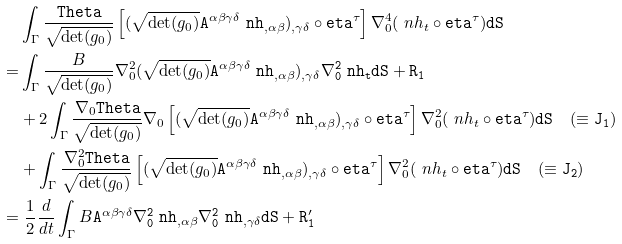Convert formula to latex. <formula><loc_0><loc_0><loc_500><loc_500>& \int _ { \Gamma } \frac { \tt T h e t a } { \sqrt { \det ( g _ { 0 } ) } } \left [ ( \sqrt { \det ( g _ { 0 } ) } \tt A ^ { \alpha \beta \gamma \delta } \ n h _ { , \alpha \beta } ) _ { , \gamma \delta } \circ \tt e t a ^ { \tau } \right ] \nabla _ { 0 } ^ { 4 } ( \ n h _ { t } \circ \tt e t a ^ { \tau } ) d S \\ = & \int _ { \Gamma } \frac { B } { \sqrt { \det ( g _ { 0 } ) } } \nabla _ { 0 } ^ { 2 } ( \sqrt { \det ( g _ { 0 } ) } \tt A ^ { \alpha \beta \gamma \delta } \ n h _ { , \alpha \beta } ) _ { , \gamma \delta } \nabla _ { 0 } ^ { 2 } \ n h _ { t } d S + R _ { 1 } \\ & + 2 \int _ { \Gamma } \frac { \nabla _ { 0 } \tt T h e t a } { \sqrt { \det ( g _ { 0 } ) } } \nabla _ { 0 } \left [ ( \sqrt { \det ( g _ { 0 } ) } \tt A ^ { \alpha \beta \gamma \delta } \ n h _ { , \alpha \beta } ) _ { , \gamma \delta } \circ \tt e t a ^ { \tau } \right ] \nabla _ { 0 } ^ { 2 } ( \ n h _ { t } \circ \tt e t a ^ { \tau } ) d S \quad ( \equiv J _ { 1 } ) \\ & + \int _ { \Gamma } \frac { \nabla _ { 0 } ^ { 2 } \tt T h e t a } { \sqrt { \det ( g _ { 0 } ) } } \left [ ( \sqrt { \det ( g _ { 0 } ) } \tt A ^ { \alpha \beta \gamma \delta } \ n h _ { , \alpha \beta } ) _ { , \gamma \delta } \circ \tt e t a ^ { \tau } \right ] \nabla _ { 0 } ^ { 2 } ( \ n h _ { t } \circ \tt e t a ^ { \tau } ) d S \quad ( \equiv J _ { 2 } ) \\ = & \ \frac { 1 } { 2 } \frac { d } { d t } \int _ { \Gamma } B \tt A ^ { \alpha \beta \gamma \delta } \nabla _ { 0 } ^ { 2 } \ n h _ { , \alpha \beta } \nabla _ { 0 } ^ { 2 } \ n h _ { , \gamma \delta } d S + R _ { 1 } ^ { \prime }</formula> 